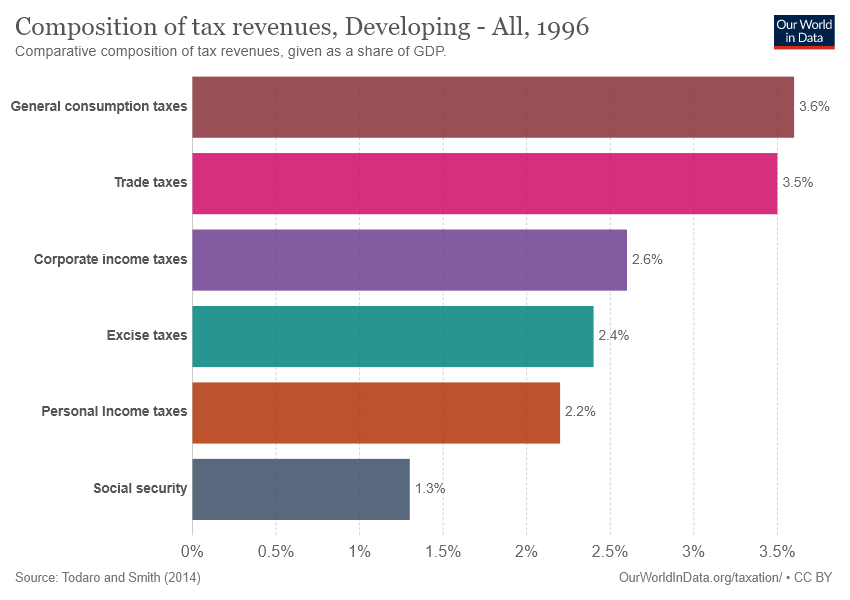Specify some key components in this picture. The average of all tax revenues is 2.6. The excise tax percentage is 0.024. 